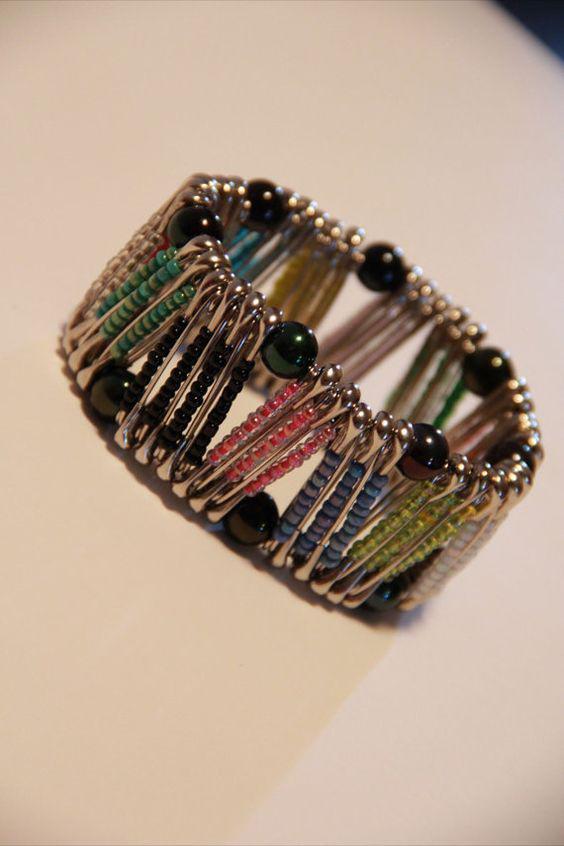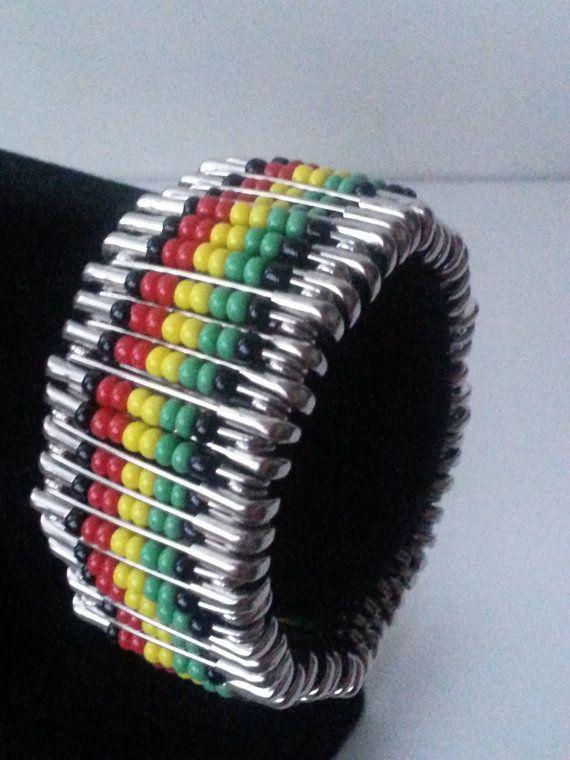The first image is the image on the left, the second image is the image on the right. Given the left and right images, does the statement "There are two unworn bracelets" hold true? Answer yes or no. Yes. The first image is the image on the left, the second image is the image on the right. For the images displayed, is the sentence "An image features a beaded bracelet displayed by a black item." factually correct? Answer yes or no. Yes. 